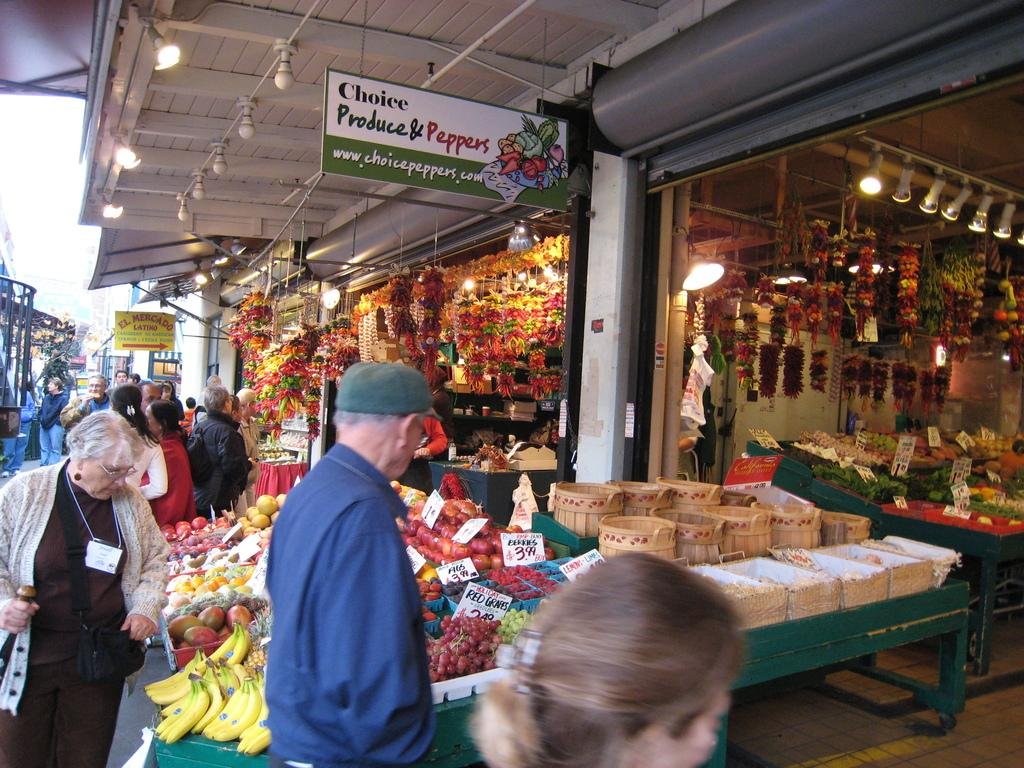What is attached to the roof in the image? There are electric bulbs attached to the roof. What can be seen on the ground in the image? There are persons standing on the road. What type of establishments are present in the image? There are stores in the image. How are the fruits and vegetables organized in the image? Fruits and vegetables are arranged in rows. How can the cost of the fruits and vegetables be determined? Price tags are associated with the fruits and vegetables. What type of exchange is taking place during the war in the image? There is no war or exchange present in the image; it features electric bulbs, persons standing on the road, stores, fruits and vegetables arranged in rows, and price tags. How does the rainstorm affect the fruits and vegetables in the image? There is no rainstorm present in the image; it is a dry scene with fruits and vegetables arranged in rows and price tags. 